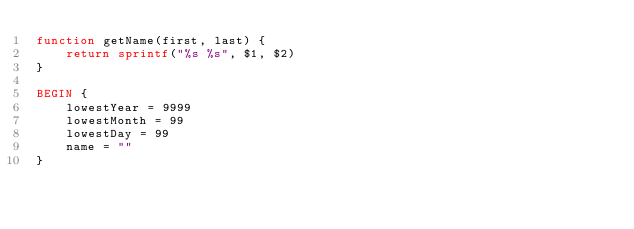Convert code to text. <code><loc_0><loc_0><loc_500><loc_500><_Awk_>function getName(first, last) {
    return sprintf("%s %s", $1, $2)
}

BEGIN {
    lowestYear = 9999
    lowestMonth = 99
    lowestDay = 99
    name = ""
}
</code> 